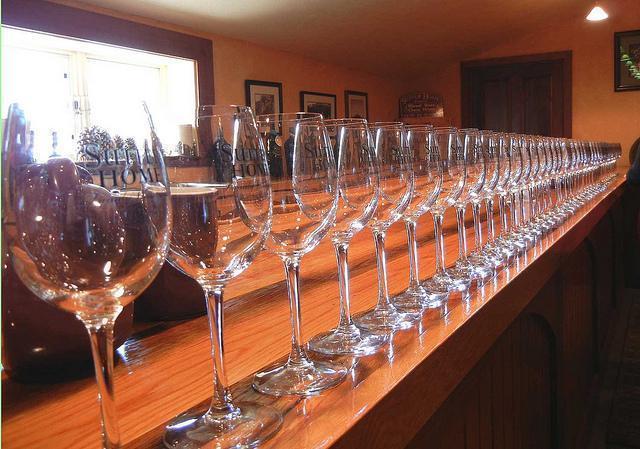What is lined up next to each other?
From the following set of four choices, select the accurate answer to respond to the question.
Options: Babies, eggs, wine glasses, pumpkins. Wine glasses. 